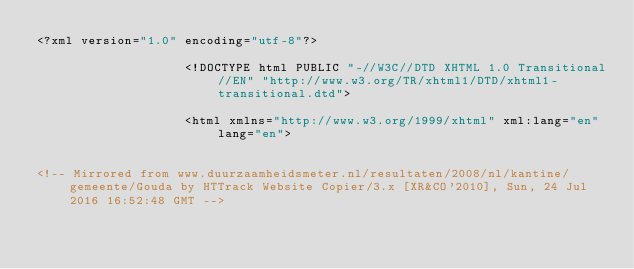Convert code to text. <code><loc_0><loc_0><loc_500><loc_500><_HTML_><?xml version="1.0" encoding="utf-8"?>

					<!DOCTYPE html PUBLIC "-//W3C//DTD XHTML 1.0 Transitional//EN" "http://www.w3.org/TR/xhtml1/DTD/xhtml1-transitional.dtd">

					<html xmlns="http://www.w3.org/1999/xhtml" xml:lang="en" lang="en">

					
<!-- Mirrored from www.duurzaamheidsmeter.nl/resultaten/2008/nl/kantine/gemeente/Gouda by HTTrack Website Copier/3.x [XR&CO'2010], Sun, 24 Jul 2016 16:52:48 GMT -->
</code> 